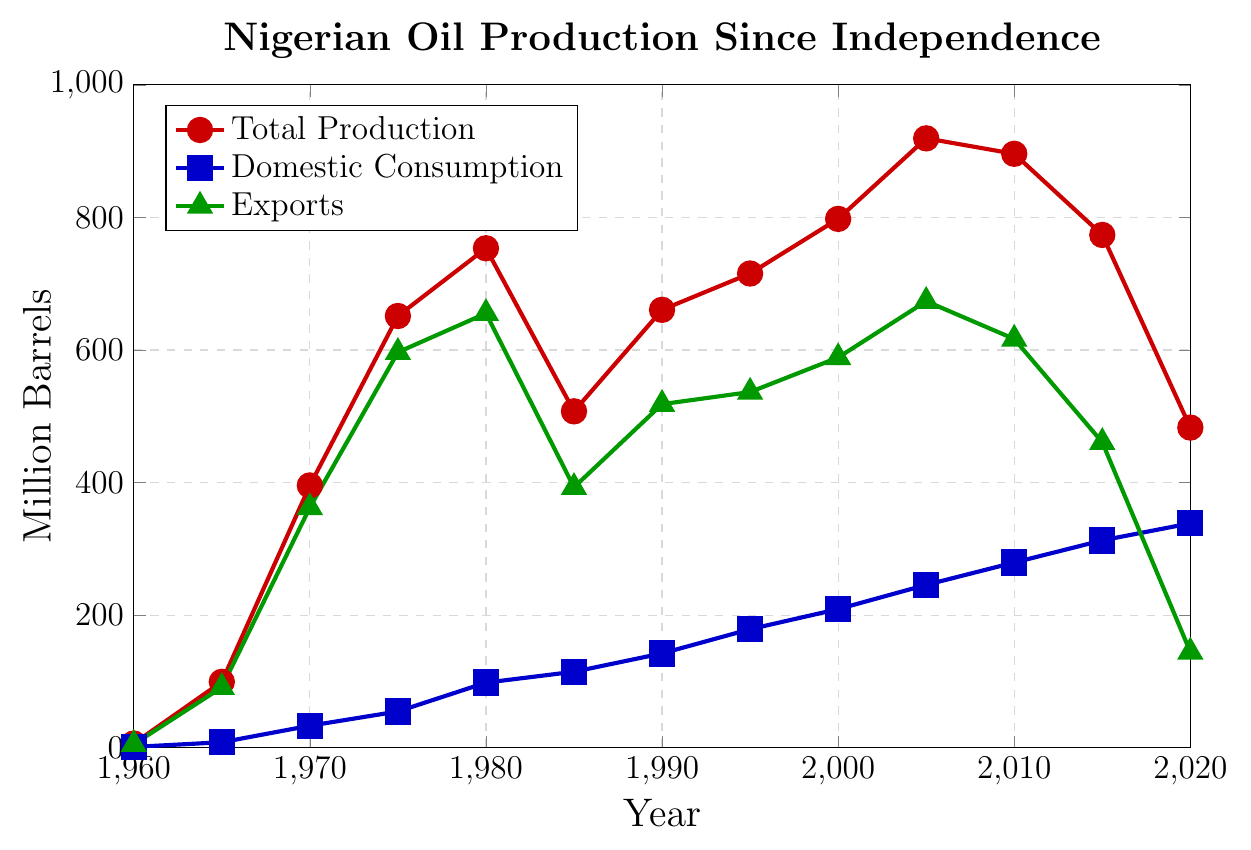Which year had the highest total oil production? Look for the year with the highest point on the total production (red) line.
Answer: 2005 How many more barrels were exported in 1980 than in 1995? Look at the export values for 1980 (655.3 million barrels) and 1995 (536.6 million barrels). Subtract the 1995 value from the 1980 value: 655.3 - 536.6.
Answer: 118.7 million barrels What was the difference between domestic consumption and exports in 2020? Find the values for domestic consumption (338.5 million barrels) and exports (144.5 million barrels) in 2020. Subtract the exports value from the domestic consumption value: 338.5 - 144.5.
Answer: 194 million barrels Which color represents domestic consumption in the chart? Observe the color of the line that marks the domestic consumption data points.
Answer: Blue Did domestic consumption ever exceed total production in any year? Compare the domestic consumption values with the total production values across all years. Notice if any domestic consumption value surpasses its corresponding total production value.
Answer: No What is the overall trend of Nigerian oil exports from 1960 to 2020? Examine the general direction of the green line representing exports over the years.
Answer: Downward trend How much did total oil production increase from 1960 to 1970? Find the total production values in 1960 (6.4 million barrels) and 1970 (395.7 million barrels). Subtract the 1960 value from the 1970 value: 395.7 - 6.4.
Answer: 389.3 million barrels During which year did domestic consumption first exceed 100 million barrels? Look for the year where the domestic consumption (blue) line first crosses the 100 million barrels mark.
Answer: 1980 What visual element indicates the highest recorded value for each data series? Identify visual markers like the highest peak for each of the three lines representing total production, domestic consumption, and exports.
Answer: Peak points on the lines Which year shows the closest figures for domestic consumption and exports? Look for the year where the blue and green lines are closest to each other. Check their corresponding values to confirm.
Answer: 1985 